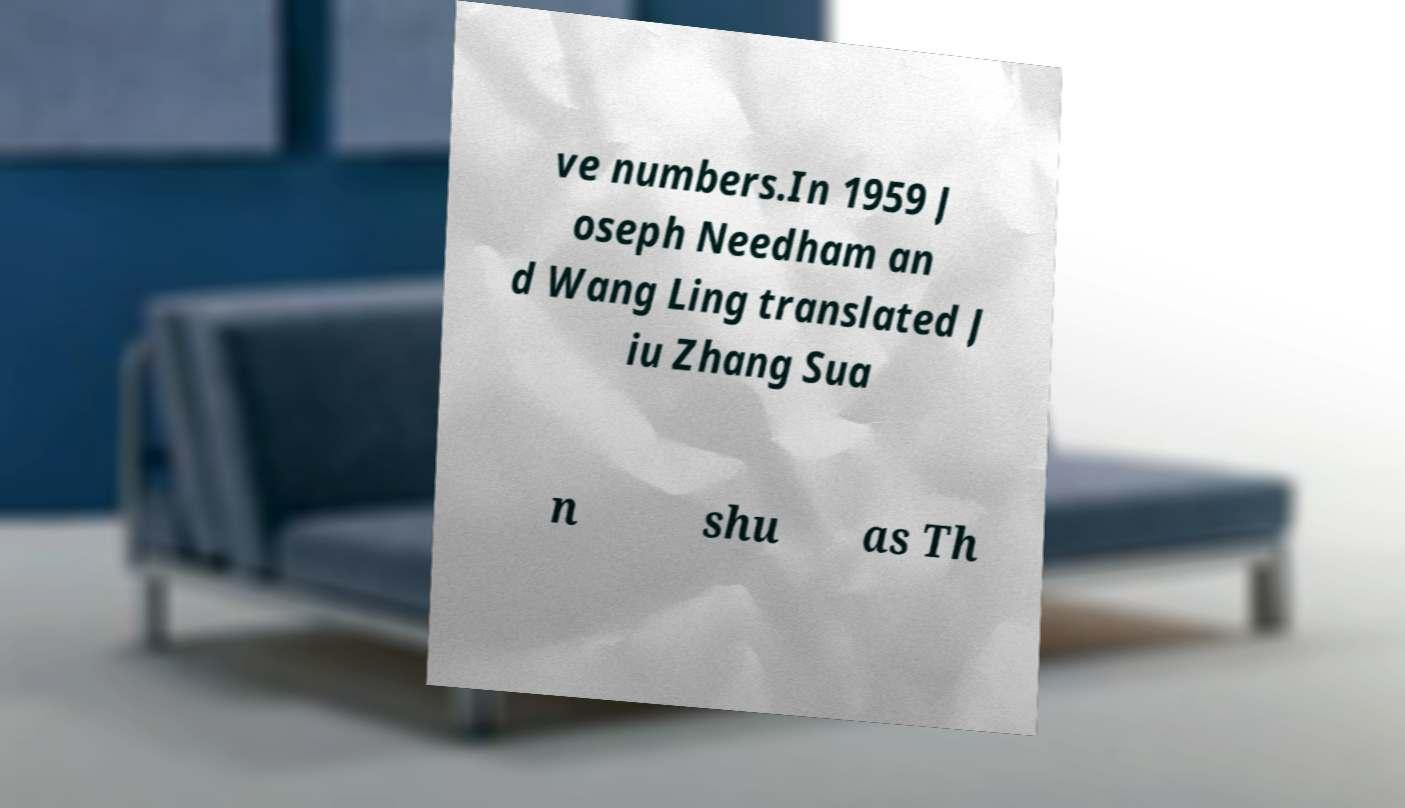What messages or text are displayed in this image? I need them in a readable, typed format. ve numbers.In 1959 J oseph Needham an d Wang Ling translated J iu Zhang Sua n shu as Th 